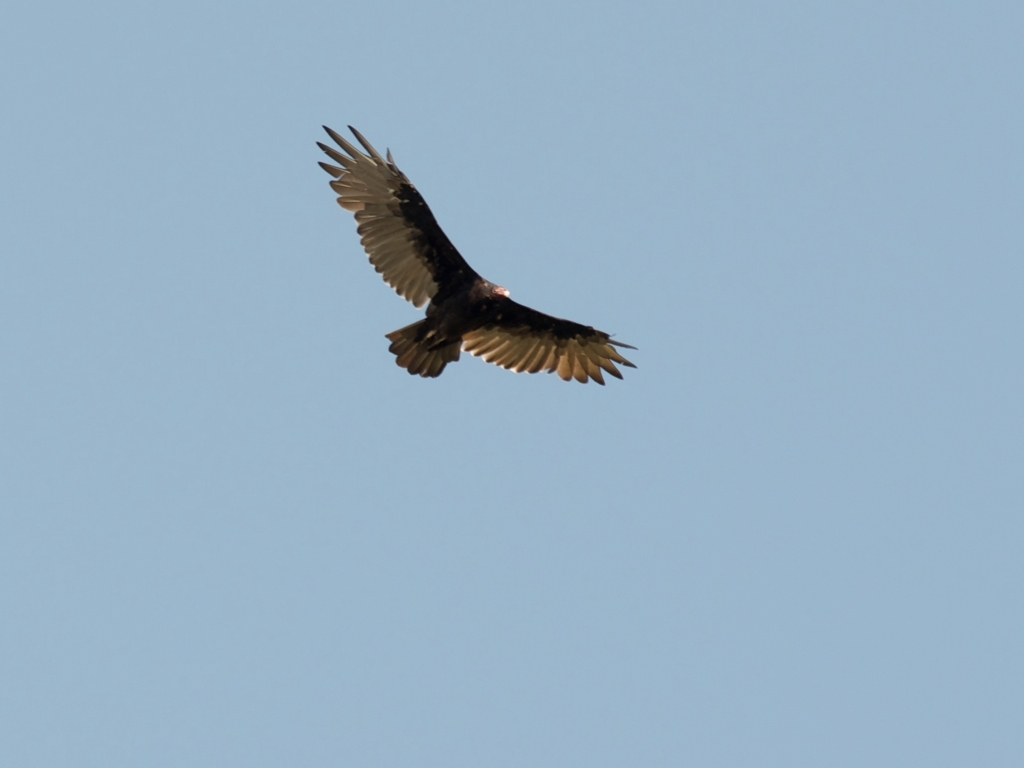Can you describe the context or environment in which the bird is flying? The bird is soaring through a clear blue sky, which suggests that it may be flying during a time of fair weather. The absence of clouds and other objects in the sky indicates that the bird is at a significant height and has a wide-open space for flying. This kind of setting could also tell us about the bird's natural habitat, potentially open fields, near water bodies, or areas where thermals are common to facilitate its soaring. 